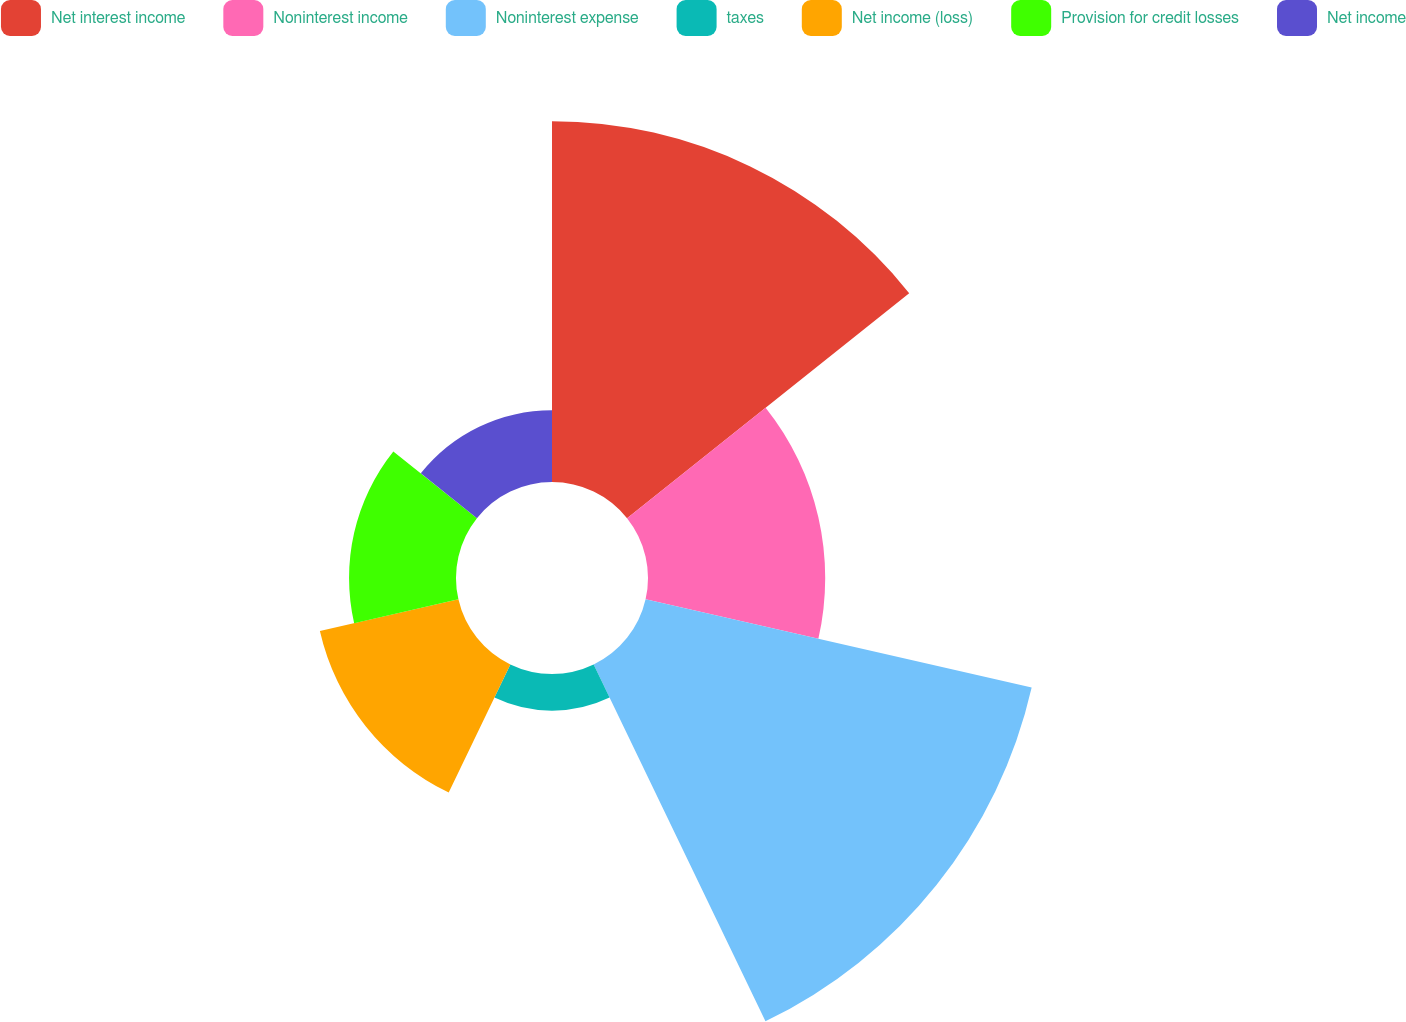Convert chart to OTSL. <chart><loc_0><loc_0><loc_500><loc_500><pie_chart><fcel>Net interest income<fcel>Noninterest income<fcel>Noninterest expense<fcel>taxes<fcel>Net income (loss)<fcel>Provision for credit losses<fcel>Net income<nl><fcel>27.94%<fcel>13.72%<fcel>30.66%<fcel>2.84%<fcel>11.0%<fcel>8.28%<fcel>5.56%<nl></chart> 